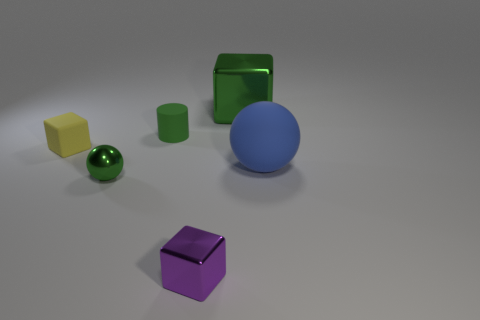What is the color of the large object that is in front of the tiny yellow rubber object?
Make the answer very short. Blue. What material is the tiny cylinder that is the same color as the tiny ball?
Provide a succinct answer. Rubber. There is a big blue rubber thing; are there any small rubber cylinders on the right side of it?
Your answer should be very brief. No. Is the number of large metal cubes greater than the number of tiny purple rubber balls?
Your answer should be compact. Yes. What is the color of the big thing that is to the right of the green shiny thing right of the shiny cube in front of the blue object?
Your answer should be very brief. Blue. There is a cylinder that is the same material as the small yellow object; what is its color?
Give a very brief answer. Green. Are there any other things that have the same size as the blue thing?
Keep it short and to the point. Yes. What number of objects are tiny green spheres that are left of the big blue rubber sphere or green objects in front of the rubber cube?
Offer a terse response. 1. Does the metallic block behind the small cylinder have the same size as the thing that is in front of the small metal sphere?
Provide a short and direct response. No. The tiny metal object that is the same shape as the large green object is what color?
Offer a very short reply. Purple. 